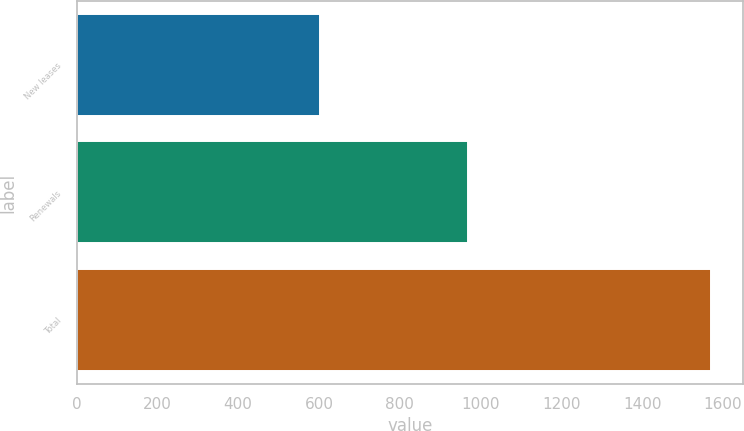Convert chart. <chart><loc_0><loc_0><loc_500><loc_500><bar_chart><fcel>New leases<fcel>Renewals<fcel>Total<nl><fcel>603<fcel>968<fcel>1571<nl></chart> 